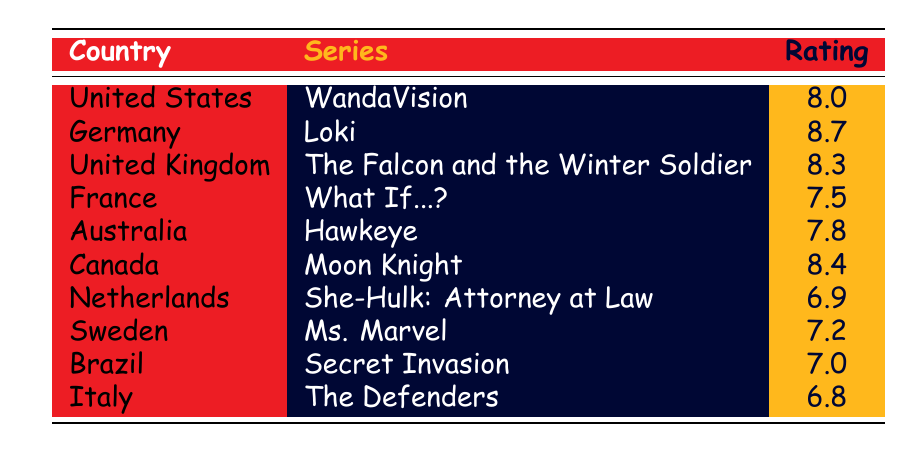What is the highest viewer rating among the Marvel series in this table? The highest rating is found by comparing the ratings listed for each series. Germany's "Loki" has the highest rating at 8.7.
Answer: 8.7 Which country has the lowest viewer rating for a Marvel series? To find the lowest rating, we look at all ratings in the table. Italy's "The Defenders" has the lowest rating at 6.8.
Answer: Italy What is the average viewer rating of the Marvel series listed in the table? To calculate the average, we sum the ratings (8.0 + 8.7 + 8.3 + 7.5 + 7.8 + 8.4 + 6.9 + 7.2 + 7.0 + 6.8 = 78.6) and divide by the number of series, which is 10. So the average is 78.6 / 10 = 7.86.
Answer: 7.86 Is "Hawkeye" rated higher than 8.0? "Hawkeye" has a rating of 7.8, which is below 8.0.
Answer: No Which series has a higher rating: "What If...?" or "Secret Invasion"? "What If...?" has a rating of 7.5, while "Secret Invasion" has a rating of 7.0. Comparing these two, "What If...?" is rated higher.
Answer: "What If...?" What is the difference between the highest and lowest ratings from the table? The highest rating is 8.7 for "Loki" and the lowest is 6.8 for "The Defenders." The difference is calculated as 8.7 - 6.8 = 1.9.
Answer: 1.9 Does Canada have a Marvel series with a rating above 8.5? Canada has "Moon Knight" with a rating of 8.4, which is not above 8.5.
Answer: No Which series was rated highest in the United Kingdom? The table shows that the series rated highest in the United Kingdom is "The Falcon and the Winter Soldier" with a rating of 8.3.
Answer: The Falcon and the Winter Soldier How many countries have a Marvel series rated above 8.0? The series rated above 8.0 include "Loki" (8.7, Germany), "Moon Knight" (8.4, Canada), "The Falcon and the Winter Soldier" (8.3, United Kingdom), and "WandaVision" (8.0, United States). That totals to 4 countries.
Answer: 4 